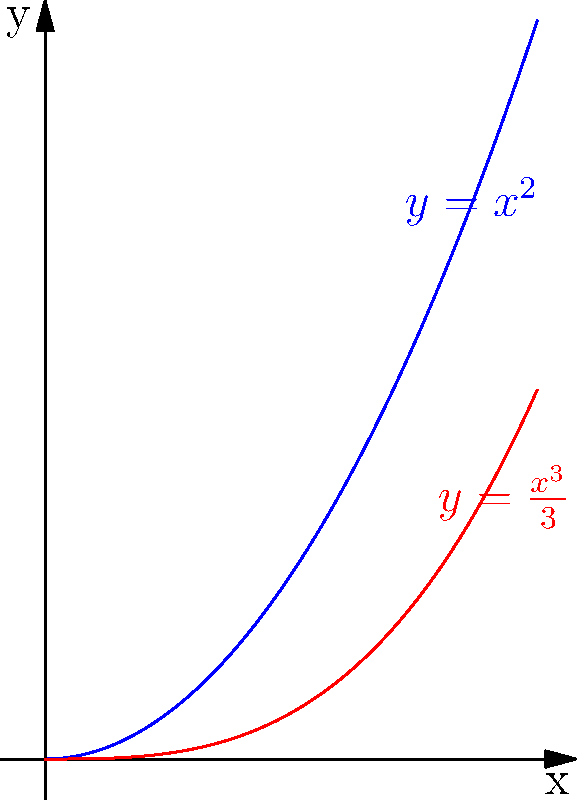Imagine you're helping your parent understand a math problem. Look at the colorful picture. The blue line shows $y=x^2$, and the red line shows $y=\frac{x^3}{3}$. Can you find the area of the green part between these two lines from $x=0$ to $x=1$? Let's solve this step by step:

1) To find the area between two curves, we use the formula:
   $$\text{Area} = \int_{a}^{b} [f(x) - g(x)] dx$$
   where $f(x)$ is the upper function and $g(x)$ is the lower function.

2) In this case, $f(x) = x^2$ (upper curve) and $g(x) = \frac{x^3}{3}$ (lower curve).

3) We need to integrate from $x=0$ to $x=1$:
   $$\text{Area} = \int_{0}^{1} [x^2 - \frac{x^3}{3}] dx$$

4) Let's integrate:
   $$\text{Area} = [\frac{x^3}{3} - \frac{x^4}{12}]_{0}^{1}$$

5) Now, let's evaluate the integral:
   $$\text{Area} = (\frac{1^3}{3} - \frac{1^4}{12}) - (\frac{0^3}{3} - \frac{0^4}{12})$$

6) Simplify:
   $$\text{Area} = (\frac{1}{3} - \frac{1}{12}) - (0 - 0) = \frac{1}{3} - \frac{1}{12} = \frac{4}{12} - \frac{1}{12} = \frac{3}{12} = \frac{1}{4}$$

Therefore, the area of the green region is $\frac{1}{4}$ square units.
Answer: $\frac{1}{4}$ square units 